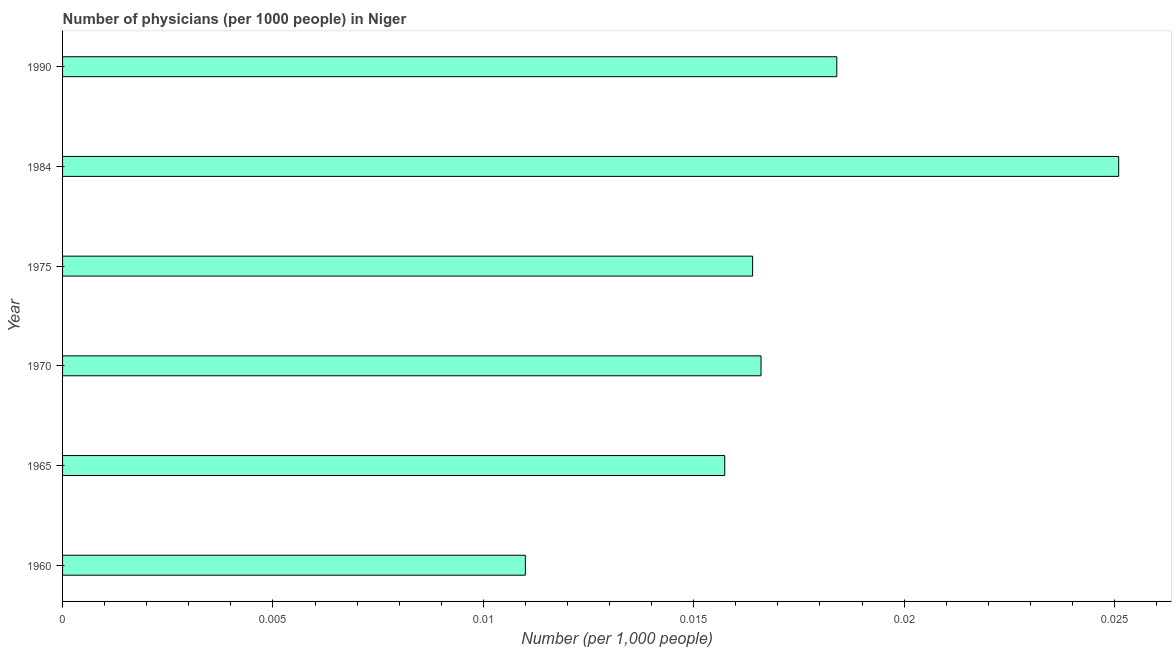What is the title of the graph?
Make the answer very short. Number of physicians (per 1000 people) in Niger. What is the label or title of the X-axis?
Provide a short and direct response. Number (per 1,0 people). What is the label or title of the Y-axis?
Give a very brief answer. Year. What is the number of physicians in 1984?
Your response must be concise. 0.03. Across all years, what is the maximum number of physicians?
Make the answer very short. 0.03. Across all years, what is the minimum number of physicians?
Give a very brief answer. 0.01. In which year was the number of physicians maximum?
Make the answer very short. 1984. In which year was the number of physicians minimum?
Your answer should be compact. 1960. What is the sum of the number of physicians?
Your response must be concise. 0.1. What is the difference between the number of physicians in 1960 and 1990?
Give a very brief answer. -0.01. What is the average number of physicians per year?
Your response must be concise. 0.02. What is the median number of physicians?
Provide a short and direct response. 0.02. In how many years, is the number of physicians greater than 0.014 ?
Your answer should be very brief. 5. Do a majority of the years between 1960 and 1970 (inclusive) have number of physicians greater than 0.02 ?
Provide a succinct answer. No. What is the ratio of the number of physicians in 1960 to that in 1965?
Your response must be concise. 0.7. Is the number of physicians in 1965 less than that in 1990?
Keep it short and to the point. Yes. What is the difference between the highest and the second highest number of physicians?
Offer a very short reply. 0.01. Is the sum of the number of physicians in 1960 and 1965 greater than the maximum number of physicians across all years?
Your answer should be very brief. Yes. What is the difference between the highest and the lowest number of physicians?
Offer a very short reply. 0.01. How many bars are there?
Provide a succinct answer. 6. Are all the bars in the graph horizontal?
Make the answer very short. Yes. How many years are there in the graph?
Offer a very short reply. 6. What is the difference between two consecutive major ticks on the X-axis?
Ensure brevity in your answer.  0.01. Are the values on the major ticks of X-axis written in scientific E-notation?
Give a very brief answer. No. What is the Number (per 1,000 people) in 1960?
Keep it short and to the point. 0.01. What is the Number (per 1,000 people) in 1965?
Offer a terse response. 0.02. What is the Number (per 1,000 people) of 1970?
Ensure brevity in your answer.  0.02. What is the Number (per 1,000 people) in 1975?
Keep it short and to the point. 0.02. What is the Number (per 1,000 people) in 1984?
Give a very brief answer. 0.03. What is the Number (per 1,000 people) of 1990?
Offer a terse response. 0.02. What is the difference between the Number (per 1,000 people) in 1960 and 1965?
Make the answer very short. -0. What is the difference between the Number (per 1,000 people) in 1960 and 1970?
Your answer should be compact. -0.01. What is the difference between the Number (per 1,000 people) in 1960 and 1975?
Keep it short and to the point. -0.01. What is the difference between the Number (per 1,000 people) in 1960 and 1984?
Offer a very short reply. -0.01. What is the difference between the Number (per 1,000 people) in 1960 and 1990?
Ensure brevity in your answer.  -0.01. What is the difference between the Number (per 1,000 people) in 1965 and 1970?
Your answer should be very brief. -0. What is the difference between the Number (per 1,000 people) in 1965 and 1975?
Keep it short and to the point. -0. What is the difference between the Number (per 1,000 people) in 1965 and 1984?
Your response must be concise. -0.01. What is the difference between the Number (per 1,000 people) in 1965 and 1990?
Provide a succinct answer. -0. What is the difference between the Number (per 1,000 people) in 1970 and 1984?
Provide a short and direct response. -0.01. What is the difference between the Number (per 1,000 people) in 1970 and 1990?
Your answer should be very brief. -0. What is the difference between the Number (per 1,000 people) in 1975 and 1984?
Offer a very short reply. -0.01. What is the difference between the Number (per 1,000 people) in 1975 and 1990?
Your answer should be very brief. -0. What is the difference between the Number (per 1,000 people) in 1984 and 1990?
Ensure brevity in your answer.  0.01. What is the ratio of the Number (per 1,000 people) in 1960 to that in 1965?
Provide a short and direct response. 0.7. What is the ratio of the Number (per 1,000 people) in 1960 to that in 1970?
Your answer should be very brief. 0.66. What is the ratio of the Number (per 1,000 people) in 1960 to that in 1975?
Your answer should be very brief. 0.67. What is the ratio of the Number (per 1,000 people) in 1960 to that in 1984?
Give a very brief answer. 0.44. What is the ratio of the Number (per 1,000 people) in 1960 to that in 1990?
Provide a succinct answer. 0.6. What is the ratio of the Number (per 1,000 people) in 1965 to that in 1970?
Your answer should be very brief. 0.95. What is the ratio of the Number (per 1,000 people) in 1965 to that in 1984?
Make the answer very short. 0.63. What is the ratio of the Number (per 1,000 people) in 1965 to that in 1990?
Provide a succinct answer. 0.85. What is the ratio of the Number (per 1,000 people) in 1970 to that in 1975?
Provide a short and direct response. 1.01. What is the ratio of the Number (per 1,000 people) in 1970 to that in 1984?
Provide a short and direct response. 0.66. What is the ratio of the Number (per 1,000 people) in 1970 to that in 1990?
Your answer should be very brief. 0.9. What is the ratio of the Number (per 1,000 people) in 1975 to that in 1984?
Keep it short and to the point. 0.65. What is the ratio of the Number (per 1,000 people) in 1975 to that in 1990?
Provide a short and direct response. 0.89. What is the ratio of the Number (per 1,000 people) in 1984 to that in 1990?
Your answer should be compact. 1.36. 